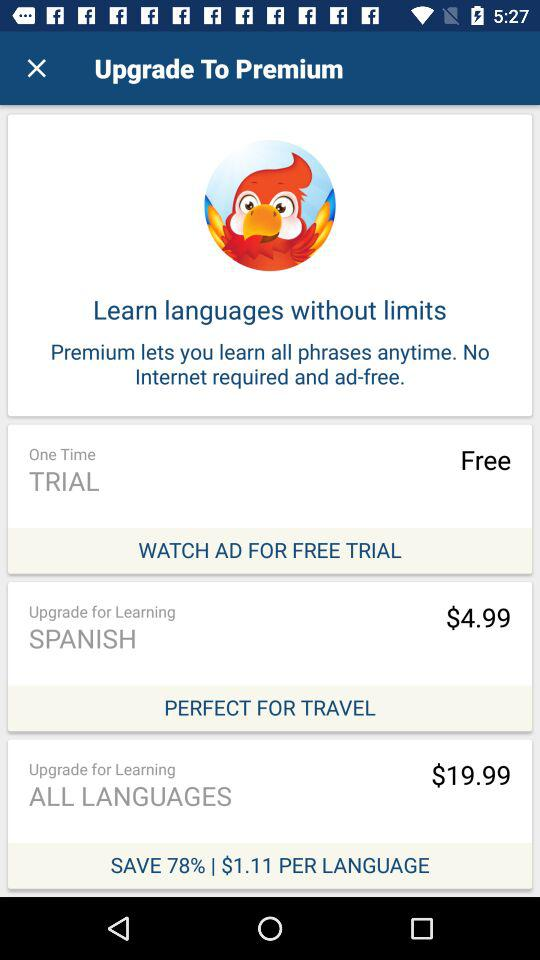What is the cost of an upgrade for learning Spanish? The cost of an upgrade for learning Spanish is $4.99. 